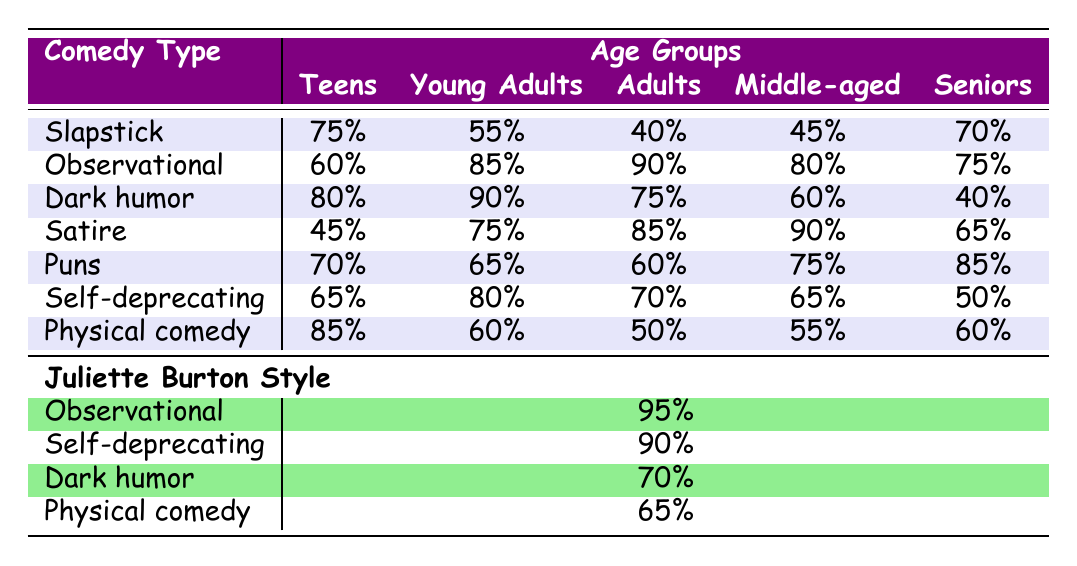What type of humor is most popular among Teens? According to the table, Slapstick has the highest popularity at 75% among Teens.
Answer: Slapstick Which age group enjoys Dark humor the most? The table shows that Young Adults have the highest percentage of Dark humor popularity at 90%.
Answer: Young Adults What is the average popularity percentage of Observational comedy across all age groups? To find the average, add the Observational percentages: 60 + 85 + 90 + 80 + 75 = 390. Divide by the total number of groups (5): 390/5 = 78.
Answer: 78 Is Physical comedy more popular among Seniors compared to Adults? The table shows Seniors with a Physical comedy popularity of 60% and Adults at 50%, so yes, it is more popular among Seniors.
Answer: Yes Which comedy type has the largest difference in popularity between Teens and Adults? The difference in popularity for Slapstick is 75% (Teens) - 40% (Adults) = 35%. For Dark humor, it's 80% - 75% = 5%. The largest difference is for Slapstick at 35%.
Answer: Slapstick What is the popularity of Self-deprecating humor among Middle-aged individuals? According to the table, the percentage of popularity for Self-deprecating humor among Middle-aged (45-59) is 65%.
Answer: 65 Which comedy type do Seniors prefer the most compared to other age groups? The highest popularity for Seniors is found in Puns at 85%. It is higher than their preference for any other comedy type.
Answer: Puns How popular is Satire in the Adults age group compared to the Seniors age group? The popularity of Satire for Adults is 85% while for Seniors it is 65%, indicating that Adults prefer Satire significantly more.
Answer: Adults What type of humor is least favored by Middle-aged individuals? Among Middle-aged individuals, Physical comedy has the least popularity at 55%.
Answer: Physical comedy 